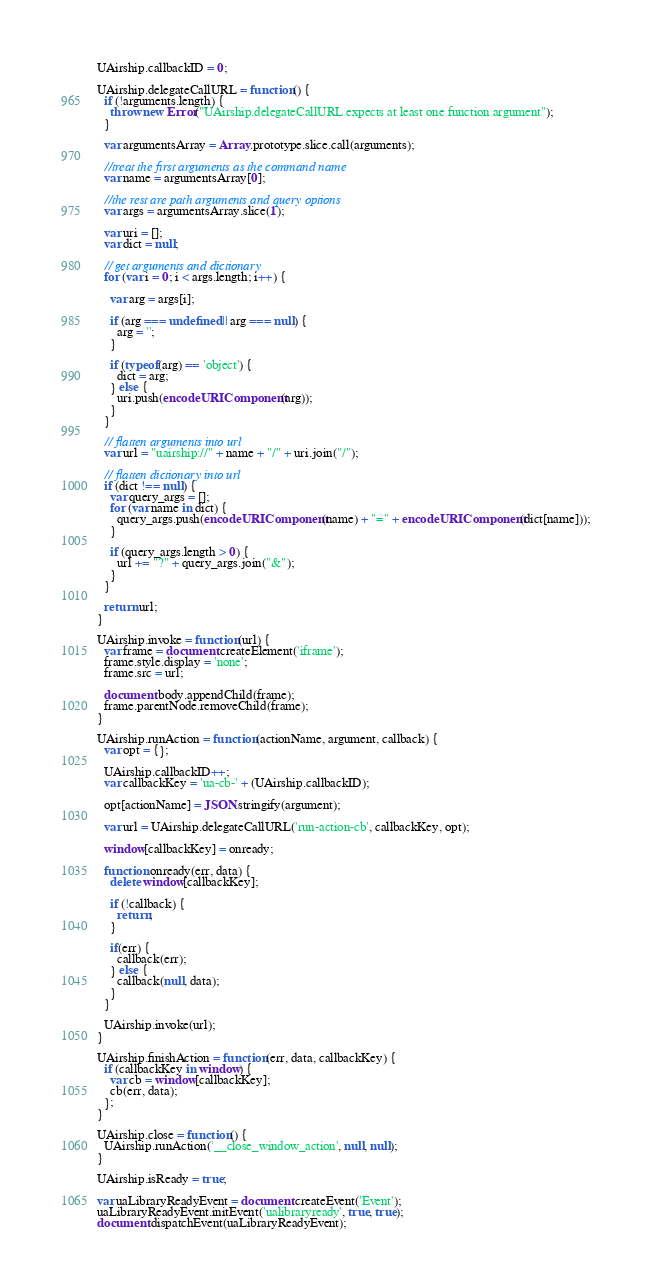<code> <loc_0><loc_0><loc_500><loc_500><_JavaScript_>UAirship.callbackID = 0;

UAirship.delegateCallURL = function() {
  if (!arguments.length) {
    throw new Error("UAirship.delegateCallURL expects at least one function argument");
  }

  var argumentsArray = Array.prototype.slice.call(arguments);

  //treat the first arguments as the command name
  var name = argumentsArray[0];

  //the rest are path arguments and query options
  var args = argumentsArray.slice(1);

  var uri = [];
  var dict = null;

  // get arguments and dictionary
  for (var i = 0; i < args.length; i++) {

    var arg = args[i];

    if (arg === undefined || arg === null) {
      arg = '';
    }

    if (typeof(arg) == 'object') {
      dict = arg;
    } else {
      uri.push(encodeURIComponent(arg));
    }
  }

  // flatten arguments into url
  var url = "uairship://" + name + "/" + uri.join("/");

  // flatten dictionary into url
  if (dict !== null) {
    var query_args = [];
    for (var name in dict) {
      query_args.push(encodeURIComponent(name) + "=" + encodeURIComponent(dict[name]));
    }

    if (query_args.length > 0) {
      url += "?" + query_args.join("&");
    }
  }

  return url;
}

UAirship.invoke = function(url) {
  var frame = document.createElement('iframe');
  frame.style.display = 'none';
  frame.src = url;

  document.body.appendChild(frame);
  frame.parentNode.removeChild(frame);
}

UAirship.runAction = function(actionName, argument, callback) {
  var opt = {};

  UAirship.callbackID++;
  var callbackKey = 'ua-cb-' + (UAirship.callbackID);

  opt[actionName] = JSON.stringify(argument);

  var url = UAirship.delegateCallURL('run-action-cb', callbackKey, opt);

  window[callbackKey] = onready;

  function onready(err, data) {
    delete window[callbackKey];

    if (!callback) {
      return;
    }

    if(err) {
      callback(err);
    } else {
      callback(null, data);
    }
  }

  UAirship.invoke(url);
}

UAirship.finishAction = function(err, data, callbackKey) {
  if (callbackKey in window) {
    var cb = window[callbackKey];
    cb(err, data);
  };
}

UAirship.close = function() {
  UAirship.runAction('__close_window_action', null, null);
}

UAirship.isReady = true;

var uaLibraryReadyEvent = document.createEvent('Event');
uaLibraryReadyEvent.initEvent('ualibraryready', true, true);
document.dispatchEvent(uaLibraryReadyEvent);
</code> 